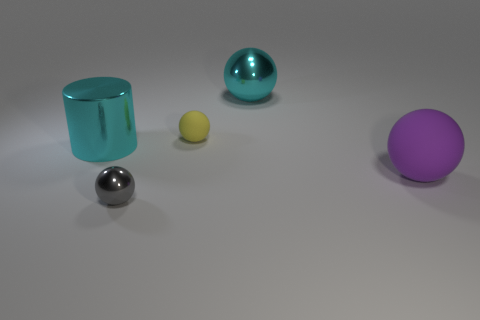Add 1 large cyan spheres. How many objects exist? 6 Subtract all balls. How many objects are left? 1 Subtract 1 purple spheres. How many objects are left? 4 Subtract all tiny gray balls. Subtract all tiny red cylinders. How many objects are left? 4 Add 3 tiny yellow balls. How many tiny yellow balls are left? 4 Add 4 cyan metallic cylinders. How many cyan metallic cylinders exist? 5 